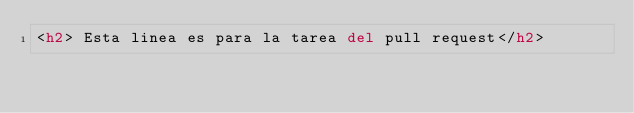Convert code to text. <code><loc_0><loc_0><loc_500><loc_500><_HTML_><h2> Esta linea es para la tarea del pull request</h2>
</code> 